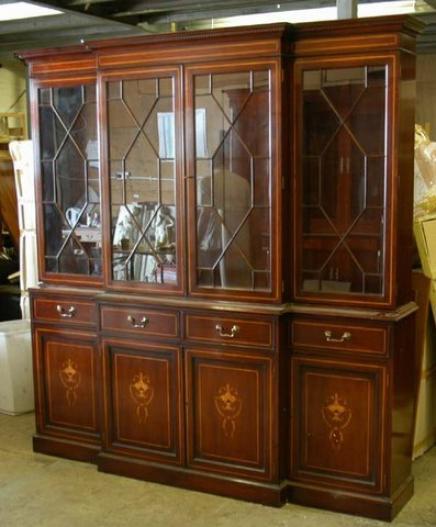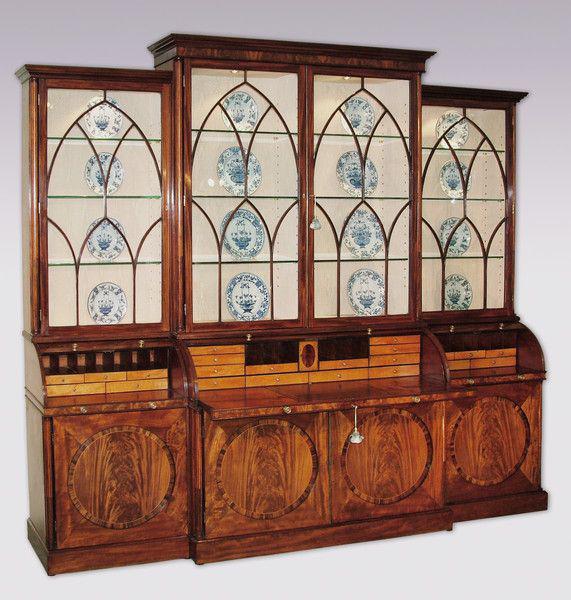The first image is the image on the left, the second image is the image on the right. For the images displayed, is the sentence "There are four drawers on the cabinet in the image on the left." factually correct? Answer yes or no. Yes. 